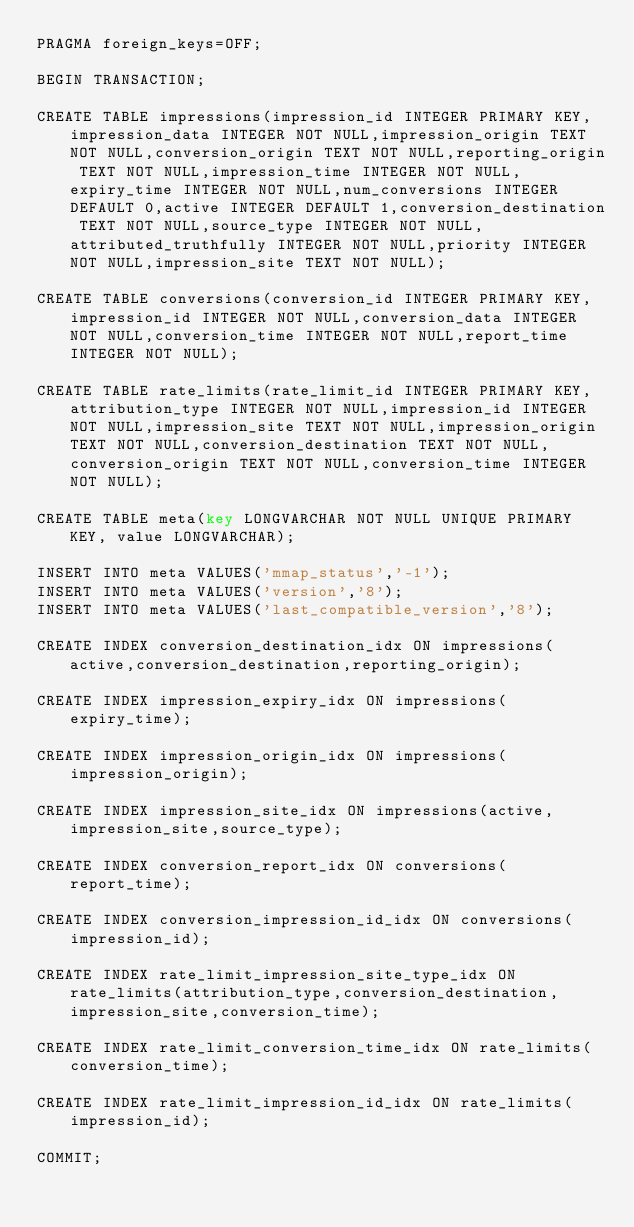Convert code to text. <code><loc_0><loc_0><loc_500><loc_500><_SQL_>PRAGMA foreign_keys=OFF;

BEGIN TRANSACTION;

CREATE TABLE impressions(impression_id INTEGER PRIMARY KEY,impression_data INTEGER NOT NULL,impression_origin TEXT NOT NULL,conversion_origin TEXT NOT NULL,reporting_origin TEXT NOT NULL,impression_time INTEGER NOT NULL,expiry_time INTEGER NOT NULL,num_conversions INTEGER DEFAULT 0,active INTEGER DEFAULT 1,conversion_destination TEXT NOT NULL,source_type INTEGER NOT NULL,attributed_truthfully INTEGER NOT NULL,priority INTEGER NOT NULL,impression_site TEXT NOT NULL);

CREATE TABLE conversions(conversion_id INTEGER PRIMARY KEY,impression_id INTEGER NOT NULL,conversion_data INTEGER NOT NULL,conversion_time INTEGER NOT NULL,report_time INTEGER NOT NULL);

CREATE TABLE rate_limits(rate_limit_id INTEGER PRIMARY KEY,attribution_type INTEGER NOT NULL,impression_id INTEGER NOT NULL,impression_site TEXT NOT NULL,impression_origin TEXT NOT NULL,conversion_destination TEXT NOT NULL,conversion_origin TEXT NOT NULL,conversion_time INTEGER NOT NULL);

CREATE TABLE meta(key LONGVARCHAR NOT NULL UNIQUE PRIMARY KEY, value LONGVARCHAR);

INSERT INTO meta VALUES('mmap_status','-1');
INSERT INTO meta VALUES('version','8');
INSERT INTO meta VALUES('last_compatible_version','8');

CREATE INDEX conversion_destination_idx ON impressions(active,conversion_destination,reporting_origin);

CREATE INDEX impression_expiry_idx ON impressions(expiry_time);

CREATE INDEX impression_origin_idx ON impressions(impression_origin);

CREATE INDEX impression_site_idx ON impressions(active,impression_site,source_type);

CREATE INDEX conversion_report_idx ON conversions(report_time);

CREATE INDEX conversion_impression_id_idx ON conversions(impression_id);

CREATE INDEX rate_limit_impression_site_type_idx ON rate_limits(attribution_type,conversion_destination,impression_site,conversion_time);

CREATE INDEX rate_limit_conversion_time_idx ON rate_limits(conversion_time);

CREATE INDEX rate_limit_impression_id_idx ON rate_limits(impression_id);

COMMIT;
</code> 